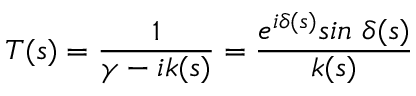<formula> <loc_0><loc_0><loc_500><loc_500>T ( s ) = { \frac { 1 } { \gamma - i k ( s ) } } = { \frac { e ^ { i \delta ( s ) } \sin \ \delta ( s ) } { k ( s ) } }</formula> 